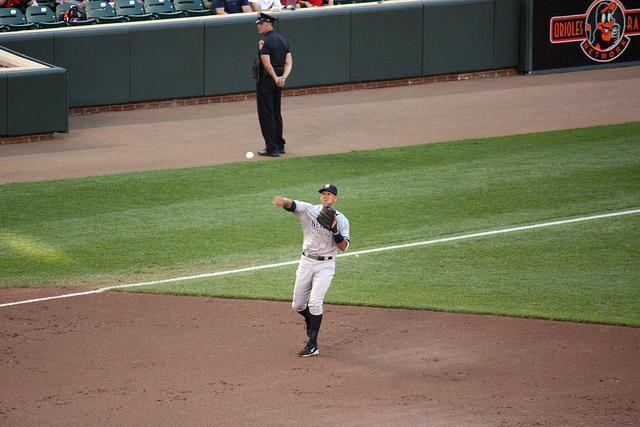How many people are in the photo?
Give a very brief answer. 2. How many horses without riders?
Give a very brief answer. 0. 